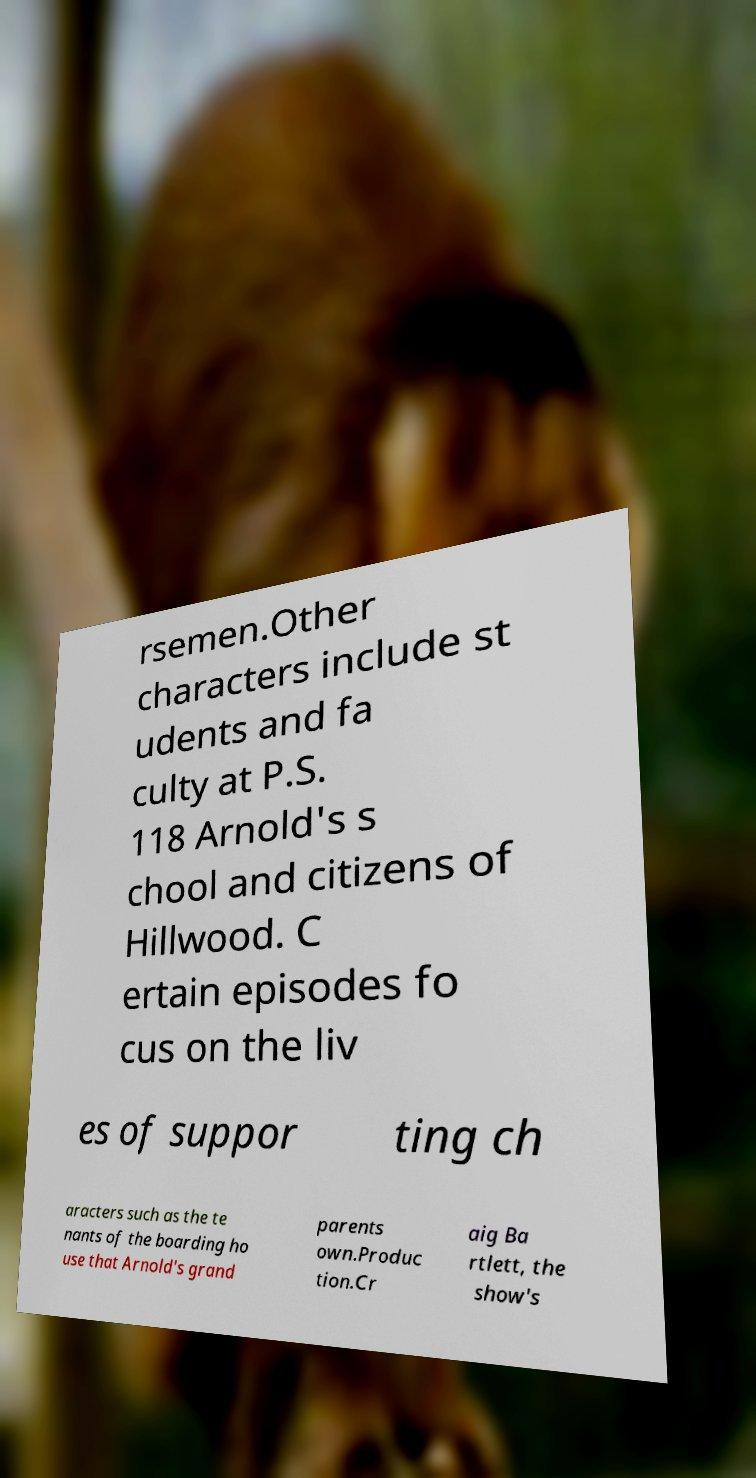Please read and relay the text visible in this image. What does it say? rsemen.Other characters include st udents and fa culty at P.S. 118 Arnold's s chool and citizens of Hillwood. C ertain episodes fo cus on the liv es of suppor ting ch aracters such as the te nants of the boarding ho use that Arnold's grand parents own.Produc tion.Cr aig Ba rtlett, the show's 